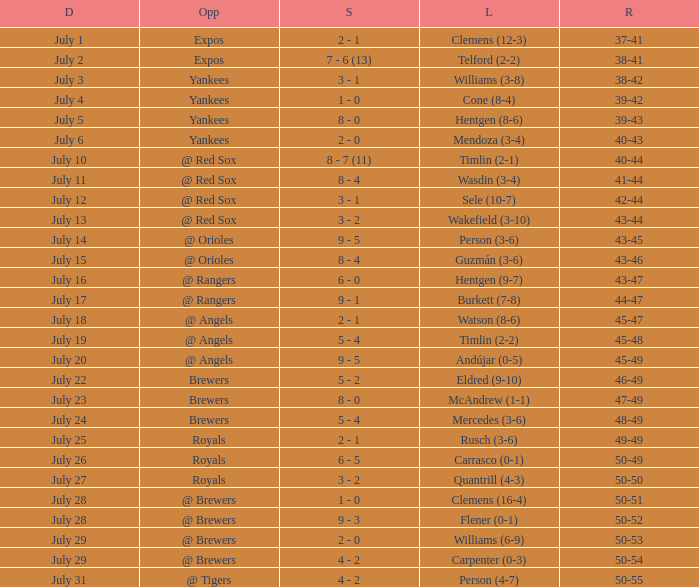What's the record on july 10? 40-44. 